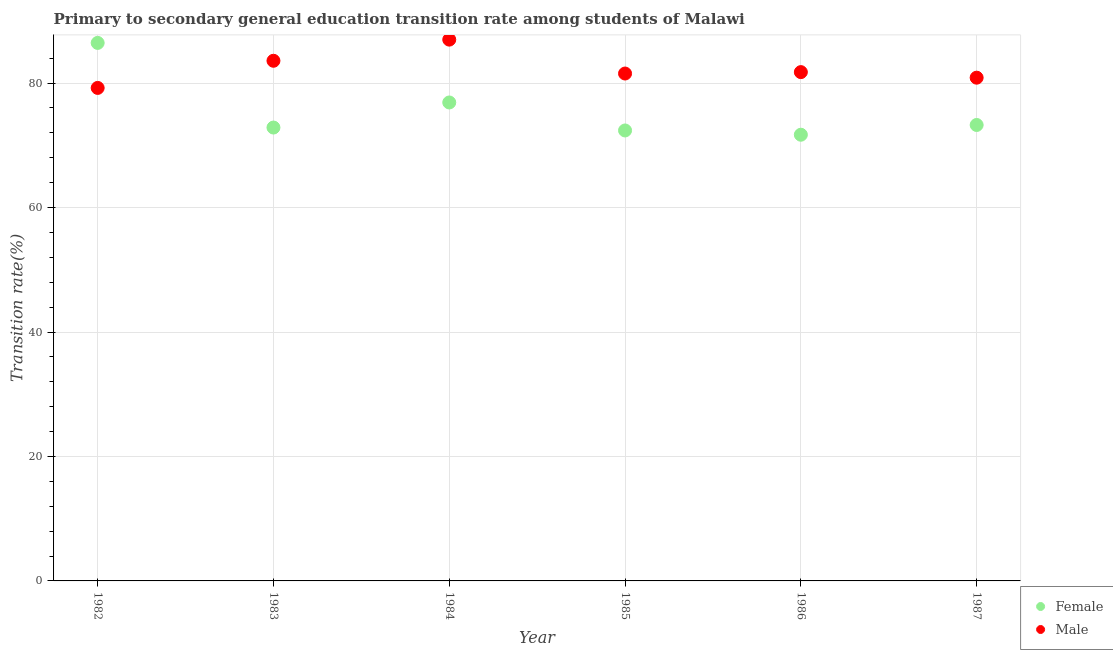Is the number of dotlines equal to the number of legend labels?
Give a very brief answer. Yes. What is the transition rate among female students in 1983?
Offer a terse response. 72.86. Across all years, what is the maximum transition rate among male students?
Offer a very short reply. 86.98. Across all years, what is the minimum transition rate among male students?
Offer a very short reply. 79.22. In which year was the transition rate among male students minimum?
Offer a terse response. 1982. What is the total transition rate among male students in the graph?
Give a very brief answer. 493.96. What is the difference between the transition rate among male students in 1982 and that in 1987?
Make the answer very short. -1.65. What is the difference between the transition rate among male students in 1987 and the transition rate among female students in 1983?
Your answer should be very brief. 8.01. What is the average transition rate among male students per year?
Keep it short and to the point. 82.33. In the year 1982, what is the difference between the transition rate among female students and transition rate among male students?
Your answer should be compact. 7.23. In how many years, is the transition rate among female students greater than 48 %?
Keep it short and to the point. 6. What is the ratio of the transition rate among male students in 1985 to that in 1986?
Give a very brief answer. 1. Is the transition rate among male students in 1983 less than that in 1985?
Offer a terse response. No. Is the difference between the transition rate among female students in 1985 and 1987 greater than the difference between the transition rate among male students in 1985 and 1987?
Offer a very short reply. No. What is the difference between the highest and the second highest transition rate among female students?
Your response must be concise. 9.57. What is the difference between the highest and the lowest transition rate among female students?
Give a very brief answer. 14.75. In how many years, is the transition rate among male students greater than the average transition rate among male students taken over all years?
Make the answer very short. 2. Is the sum of the transition rate among female students in 1982 and 1985 greater than the maximum transition rate among male students across all years?
Offer a terse response. Yes. Is the transition rate among female students strictly less than the transition rate among male students over the years?
Keep it short and to the point. No. How many years are there in the graph?
Give a very brief answer. 6. What is the difference between two consecutive major ticks on the Y-axis?
Your answer should be very brief. 20. Does the graph contain any zero values?
Ensure brevity in your answer.  No. Does the graph contain grids?
Offer a terse response. Yes. What is the title of the graph?
Provide a succinct answer. Primary to secondary general education transition rate among students of Malawi. Does "Grants" appear as one of the legend labels in the graph?
Ensure brevity in your answer.  No. What is the label or title of the Y-axis?
Your response must be concise. Transition rate(%). What is the Transition rate(%) of Female in 1982?
Ensure brevity in your answer.  86.46. What is the Transition rate(%) in Male in 1982?
Provide a succinct answer. 79.22. What is the Transition rate(%) in Female in 1983?
Keep it short and to the point. 72.86. What is the Transition rate(%) in Male in 1983?
Give a very brief answer. 83.59. What is the Transition rate(%) in Female in 1984?
Ensure brevity in your answer.  76.89. What is the Transition rate(%) in Male in 1984?
Make the answer very short. 86.98. What is the Transition rate(%) in Female in 1985?
Your response must be concise. 72.39. What is the Transition rate(%) in Male in 1985?
Make the answer very short. 81.54. What is the Transition rate(%) of Female in 1986?
Offer a terse response. 71.7. What is the Transition rate(%) of Male in 1986?
Provide a short and direct response. 81.76. What is the Transition rate(%) in Female in 1987?
Offer a very short reply. 73.27. What is the Transition rate(%) in Male in 1987?
Keep it short and to the point. 80.87. Across all years, what is the maximum Transition rate(%) of Female?
Your answer should be compact. 86.46. Across all years, what is the maximum Transition rate(%) of Male?
Ensure brevity in your answer.  86.98. Across all years, what is the minimum Transition rate(%) in Female?
Offer a terse response. 71.7. Across all years, what is the minimum Transition rate(%) in Male?
Provide a succinct answer. 79.22. What is the total Transition rate(%) in Female in the graph?
Keep it short and to the point. 453.56. What is the total Transition rate(%) in Male in the graph?
Your answer should be very brief. 493.96. What is the difference between the Transition rate(%) in Female in 1982 and that in 1983?
Offer a terse response. 13.6. What is the difference between the Transition rate(%) of Male in 1982 and that in 1983?
Keep it short and to the point. -4.36. What is the difference between the Transition rate(%) in Female in 1982 and that in 1984?
Keep it short and to the point. 9.57. What is the difference between the Transition rate(%) of Male in 1982 and that in 1984?
Provide a succinct answer. -7.76. What is the difference between the Transition rate(%) of Female in 1982 and that in 1985?
Give a very brief answer. 14.07. What is the difference between the Transition rate(%) of Male in 1982 and that in 1985?
Offer a terse response. -2.31. What is the difference between the Transition rate(%) in Female in 1982 and that in 1986?
Offer a very short reply. 14.75. What is the difference between the Transition rate(%) of Male in 1982 and that in 1986?
Make the answer very short. -2.54. What is the difference between the Transition rate(%) of Female in 1982 and that in 1987?
Give a very brief answer. 13.19. What is the difference between the Transition rate(%) of Male in 1982 and that in 1987?
Ensure brevity in your answer.  -1.65. What is the difference between the Transition rate(%) in Female in 1983 and that in 1984?
Make the answer very short. -4.03. What is the difference between the Transition rate(%) of Male in 1983 and that in 1984?
Your response must be concise. -3.4. What is the difference between the Transition rate(%) in Female in 1983 and that in 1985?
Make the answer very short. 0.47. What is the difference between the Transition rate(%) of Male in 1983 and that in 1985?
Provide a short and direct response. 2.05. What is the difference between the Transition rate(%) of Female in 1983 and that in 1986?
Provide a short and direct response. 1.15. What is the difference between the Transition rate(%) in Male in 1983 and that in 1986?
Provide a short and direct response. 1.82. What is the difference between the Transition rate(%) of Female in 1983 and that in 1987?
Provide a succinct answer. -0.41. What is the difference between the Transition rate(%) of Male in 1983 and that in 1987?
Your answer should be compact. 2.72. What is the difference between the Transition rate(%) of Female in 1984 and that in 1985?
Offer a terse response. 4.5. What is the difference between the Transition rate(%) of Male in 1984 and that in 1985?
Your answer should be compact. 5.45. What is the difference between the Transition rate(%) in Female in 1984 and that in 1986?
Offer a very short reply. 5.18. What is the difference between the Transition rate(%) of Male in 1984 and that in 1986?
Keep it short and to the point. 5.22. What is the difference between the Transition rate(%) of Female in 1984 and that in 1987?
Keep it short and to the point. 3.62. What is the difference between the Transition rate(%) in Male in 1984 and that in 1987?
Offer a very short reply. 6.11. What is the difference between the Transition rate(%) in Female in 1985 and that in 1986?
Give a very brief answer. 0.69. What is the difference between the Transition rate(%) of Male in 1985 and that in 1986?
Provide a short and direct response. -0.23. What is the difference between the Transition rate(%) in Female in 1985 and that in 1987?
Your answer should be very brief. -0.88. What is the difference between the Transition rate(%) in Male in 1985 and that in 1987?
Keep it short and to the point. 0.67. What is the difference between the Transition rate(%) of Female in 1986 and that in 1987?
Your response must be concise. -1.57. What is the difference between the Transition rate(%) in Male in 1986 and that in 1987?
Your answer should be very brief. 0.89. What is the difference between the Transition rate(%) in Female in 1982 and the Transition rate(%) in Male in 1983?
Provide a succinct answer. 2.87. What is the difference between the Transition rate(%) of Female in 1982 and the Transition rate(%) of Male in 1984?
Make the answer very short. -0.53. What is the difference between the Transition rate(%) in Female in 1982 and the Transition rate(%) in Male in 1985?
Offer a terse response. 4.92. What is the difference between the Transition rate(%) in Female in 1982 and the Transition rate(%) in Male in 1986?
Ensure brevity in your answer.  4.69. What is the difference between the Transition rate(%) in Female in 1982 and the Transition rate(%) in Male in 1987?
Offer a terse response. 5.59. What is the difference between the Transition rate(%) of Female in 1983 and the Transition rate(%) of Male in 1984?
Your answer should be compact. -14.13. What is the difference between the Transition rate(%) in Female in 1983 and the Transition rate(%) in Male in 1985?
Give a very brief answer. -8.68. What is the difference between the Transition rate(%) in Female in 1983 and the Transition rate(%) in Male in 1986?
Offer a very short reply. -8.91. What is the difference between the Transition rate(%) of Female in 1983 and the Transition rate(%) of Male in 1987?
Your response must be concise. -8.01. What is the difference between the Transition rate(%) in Female in 1984 and the Transition rate(%) in Male in 1985?
Offer a terse response. -4.65. What is the difference between the Transition rate(%) in Female in 1984 and the Transition rate(%) in Male in 1986?
Keep it short and to the point. -4.88. What is the difference between the Transition rate(%) in Female in 1984 and the Transition rate(%) in Male in 1987?
Provide a short and direct response. -3.98. What is the difference between the Transition rate(%) of Female in 1985 and the Transition rate(%) of Male in 1986?
Offer a very short reply. -9.38. What is the difference between the Transition rate(%) in Female in 1985 and the Transition rate(%) in Male in 1987?
Give a very brief answer. -8.48. What is the difference between the Transition rate(%) of Female in 1986 and the Transition rate(%) of Male in 1987?
Offer a very short reply. -9.17. What is the average Transition rate(%) in Female per year?
Provide a succinct answer. 75.59. What is the average Transition rate(%) in Male per year?
Provide a succinct answer. 82.33. In the year 1982, what is the difference between the Transition rate(%) in Female and Transition rate(%) in Male?
Give a very brief answer. 7.23. In the year 1983, what is the difference between the Transition rate(%) in Female and Transition rate(%) in Male?
Your answer should be compact. -10.73. In the year 1984, what is the difference between the Transition rate(%) of Female and Transition rate(%) of Male?
Offer a terse response. -10.1. In the year 1985, what is the difference between the Transition rate(%) of Female and Transition rate(%) of Male?
Ensure brevity in your answer.  -9.15. In the year 1986, what is the difference between the Transition rate(%) of Female and Transition rate(%) of Male?
Your answer should be compact. -10.06. In the year 1987, what is the difference between the Transition rate(%) in Female and Transition rate(%) in Male?
Offer a very short reply. -7.6. What is the ratio of the Transition rate(%) in Female in 1982 to that in 1983?
Your response must be concise. 1.19. What is the ratio of the Transition rate(%) in Male in 1982 to that in 1983?
Keep it short and to the point. 0.95. What is the ratio of the Transition rate(%) of Female in 1982 to that in 1984?
Your response must be concise. 1.12. What is the ratio of the Transition rate(%) of Male in 1982 to that in 1984?
Provide a succinct answer. 0.91. What is the ratio of the Transition rate(%) in Female in 1982 to that in 1985?
Offer a terse response. 1.19. What is the ratio of the Transition rate(%) of Male in 1982 to that in 1985?
Keep it short and to the point. 0.97. What is the ratio of the Transition rate(%) of Female in 1982 to that in 1986?
Your answer should be very brief. 1.21. What is the ratio of the Transition rate(%) in Male in 1982 to that in 1986?
Your response must be concise. 0.97. What is the ratio of the Transition rate(%) in Female in 1982 to that in 1987?
Your answer should be very brief. 1.18. What is the ratio of the Transition rate(%) of Male in 1982 to that in 1987?
Offer a very short reply. 0.98. What is the ratio of the Transition rate(%) of Female in 1983 to that in 1984?
Your answer should be compact. 0.95. What is the ratio of the Transition rate(%) of Male in 1983 to that in 1984?
Your response must be concise. 0.96. What is the ratio of the Transition rate(%) in Female in 1983 to that in 1985?
Provide a succinct answer. 1.01. What is the ratio of the Transition rate(%) in Male in 1983 to that in 1985?
Your answer should be compact. 1.03. What is the ratio of the Transition rate(%) of Female in 1983 to that in 1986?
Provide a short and direct response. 1.02. What is the ratio of the Transition rate(%) of Male in 1983 to that in 1986?
Offer a terse response. 1.02. What is the ratio of the Transition rate(%) of Male in 1983 to that in 1987?
Ensure brevity in your answer.  1.03. What is the ratio of the Transition rate(%) of Female in 1984 to that in 1985?
Ensure brevity in your answer.  1.06. What is the ratio of the Transition rate(%) of Male in 1984 to that in 1985?
Give a very brief answer. 1.07. What is the ratio of the Transition rate(%) in Female in 1984 to that in 1986?
Your response must be concise. 1.07. What is the ratio of the Transition rate(%) in Male in 1984 to that in 1986?
Offer a terse response. 1.06. What is the ratio of the Transition rate(%) of Female in 1984 to that in 1987?
Offer a terse response. 1.05. What is the ratio of the Transition rate(%) of Male in 1984 to that in 1987?
Your answer should be compact. 1.08. What is the ratio of the Transition rate(%) in Female in 1985 to that in 1986?
Offer a very short reply. 1.01. What is the ratio of the Transition rate(%) in Male in 1985 to that in 1986?
Make the answer very short. 1. What is the ratio of the Transition rate(%) of Female in 1985 to that in 1987?
Ensure brevity in your answer.  0.99. What is the ratio of the Transition rate(%) in Male in 1985 to that in 1987?
Your response must be concise. 1.01. What is the ratio of the Transition rate(%) in Female in 1986 to that in 1987?
Provide a succinct answer. 0.98. What is the ratio of the Transition rate(%) of Male in 1986 to that in 1987?
Give a very brief answer. 1.01. What is the difference between the highest and the second highest Transition rate(%) of Female?
Your response must be concise. 9.57. What is the difference between the highest and the second highest Transition rate(%) in Male?
Your answer should be very brief. 3.4. What is the difference between the highest and the lowest Transition rate(%) in Female?
Make the answer very short. 14.75. What is the difference between the highest and the lowest Transition rate(%) of Male?
Offer a very short reply. 7.76. 